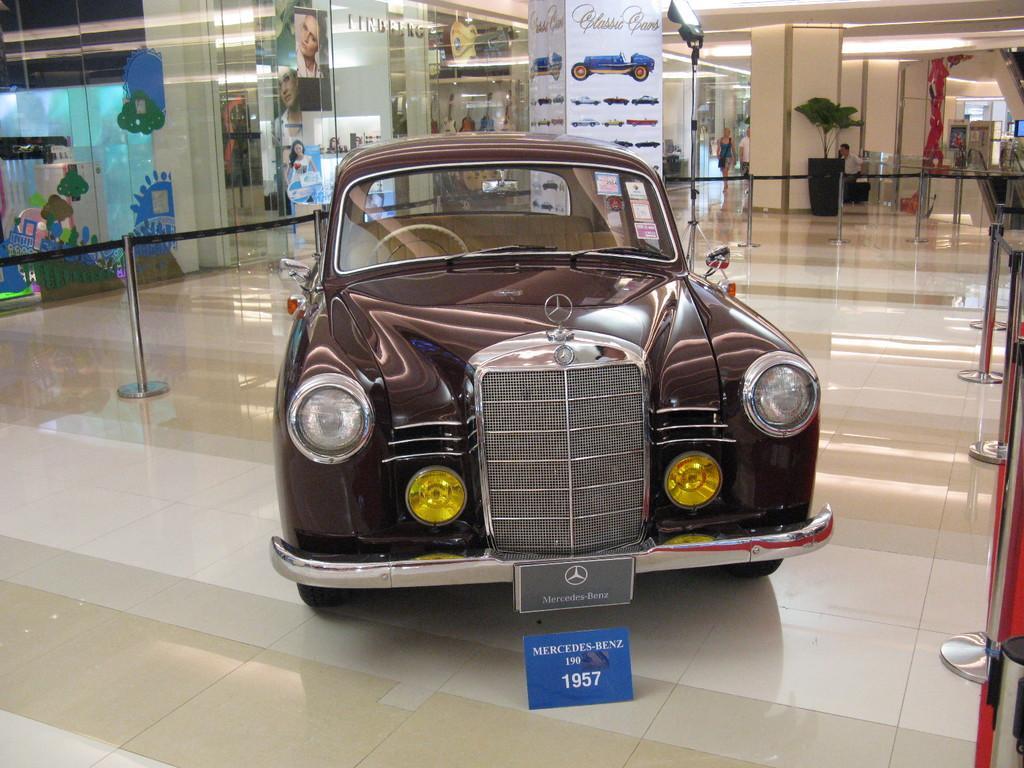Describe this image in one or two sentences. In this image we can see a car on the floor, rope and pole barriers, light on a stand, plants, posters on the glasses, objects and lights on the ceiling. 